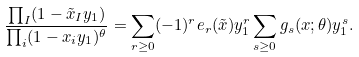Convert formula to latex. <formula><loc_0><loc_0><loc_500><loc_500>\frac { \prod _ { I } ( 1 - \tilde { x } _ { I } y _ { 1 } ) } { \prod _ { i } ( 1 - x _ { i } y _ { 1 } ) ^ { \theta } } = \sum _ { r \geq 0 } ( - 1 ) ^ { r } e _ { r } ( \tilde { x } ) y _ { 1 } ^ { r } \sum _ { s \geq 0 } g _ { s } ( x ; \theta ) y _ { 1 } ^ { s } .</formula> 